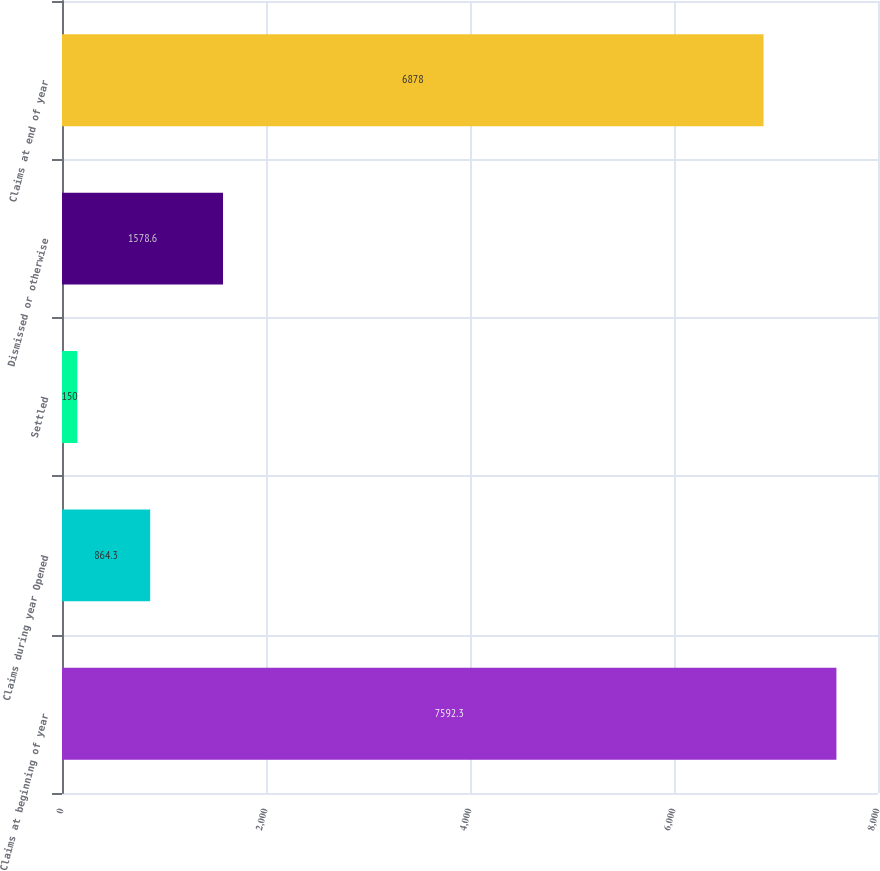Convert chart to OTSL. <chart><loc_0><loc_0><loc_500><loc_500><bar_chart><fcel>Claims at beginning of year<fcel>Claims during year Opened<fcel>Settled<fcel>Dismissed or otherwise<fcel>Claims at end of year<nl><fcel>7592.3<fcel>864.3<fcel>150<fcel>1578.6<fcel>6878<nl></chart> 